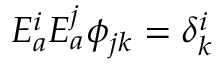Convert formula to latex. <formula><loc_0><loc_0><loc_500><loc_500>E _ { a } ^ { i } E _ { a } ^ { j } \phi _ { j k } = \delta _ { k } ^ { i }</formula> 